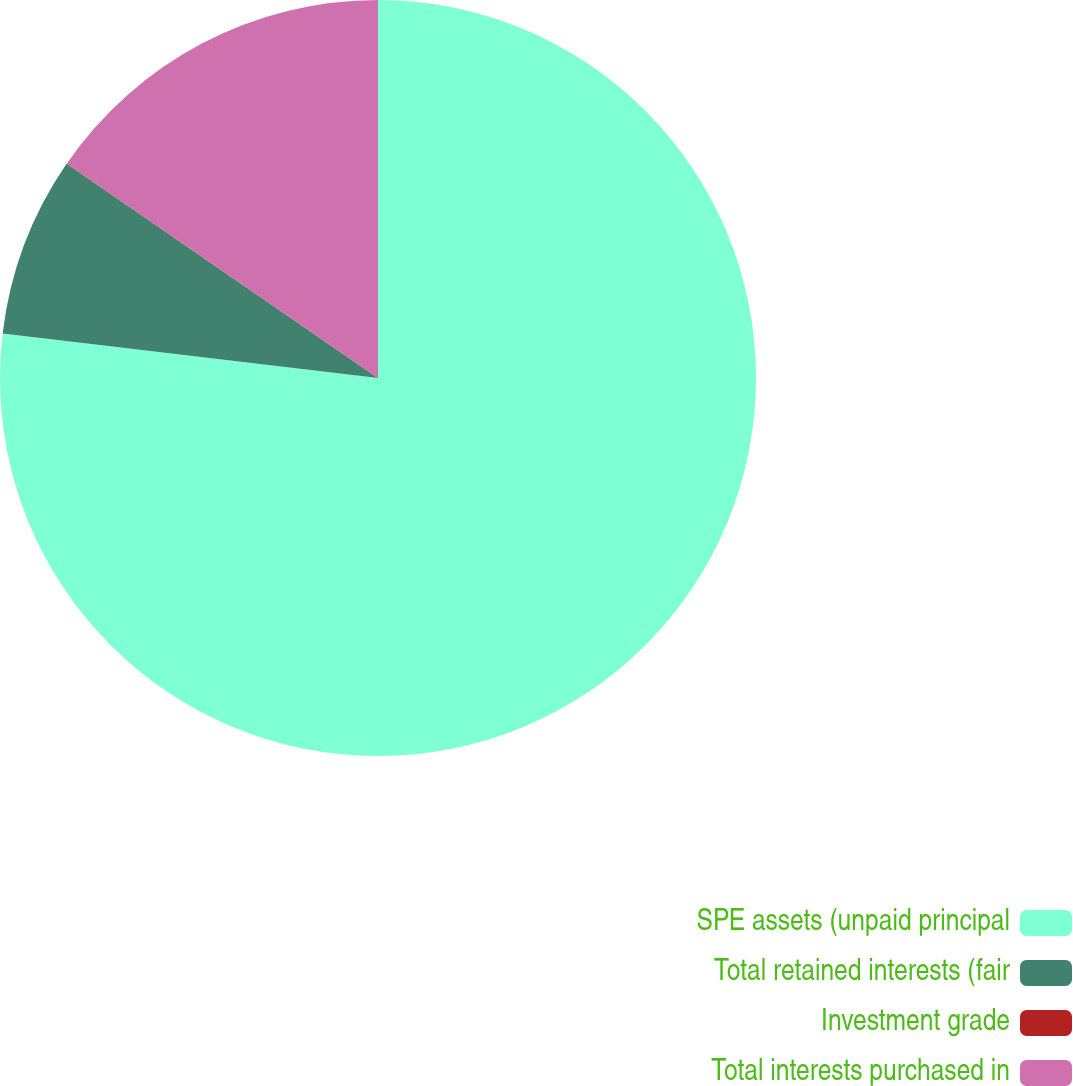Convert chart to OTSL. <chart><loc_0><loc_0><loc_500><loc_500><pie_chart><fcel>SPE assets (unpaid principal<fcel>Total retained interests (fair<fcel>Investment grade<fcel>Total interests purchased in<nl><fcel>76.88%<fcel>7.71%<fcel>0.02%<fcel>15.39%<nl></chart> 